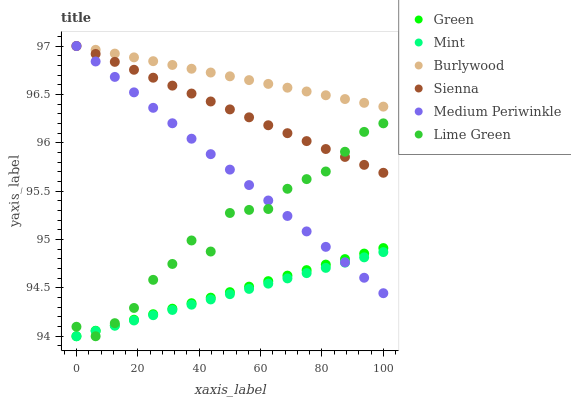Does Mint have the minimum area under the curve?
Answer yes or no. Yes. Does Burlywood have the maximum area under the curve?
Answer yes or no. Yes. Does Lime Green have the minimum area under the curve?
Answer yes or no. No. Does Lime Green have the maximum area under the curve?
Answer yes or no. No. Is Mint the smoothest?
Answer yes or no. Yes. Is Lime Green the roughest?
Answer yes or no. Yes. Is Medium Periwinkle the smoothest?
Answer yes or no. No. Is Medium Periwinkle the roughest?
Answer yes or no. No. Does Lime Green have the lowest value?
Answer yes or no. Yes. Does Medium Periwinkle have the lowest value?
Answer yes or no. No. Does Sienna have the highest value?
Answer yes or no. Yes. Does Lime Green have the highest value?
Answer yes or no. No. Is Green less than Burlywood?
Answer yes or no. Yes. Is Burlywood greater than Green?
Answer yes or no. Yes. Does Green intersect Lime Green?
Answer yes or no. Yes. Is Green less than Lime Green?
Answer yes or no. No. Is Green greater than Lime Green?
Answer yes or no. No. Does Green intersect Burlywood?
Answer yes or no. No. 